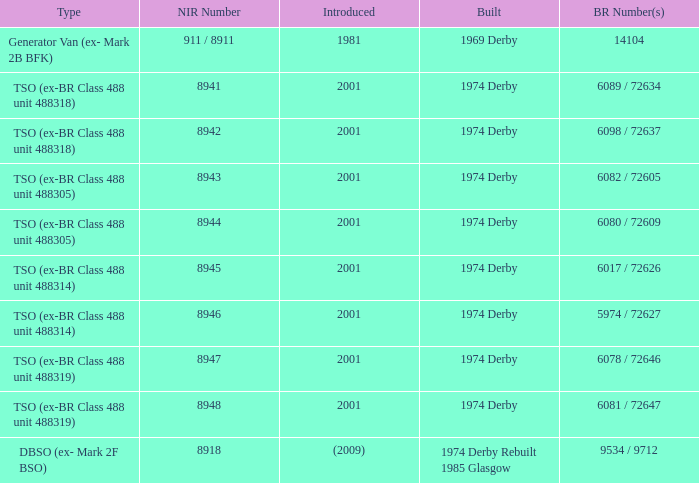Which NIR number is for the tso (ex-br class 488 unit 488305) type that has a 6082 / 72605 BR number? 8943.0. Could you parse the entire table? {'header': ['Type', 'NIR Number', 'Introduced', 'Built', 'BR Number(s)'], 'rows': [['Generator Van (ex- Mark 2B BFK)', '911 / 8911', '1981', '1969 Derby', '14104'], ['TSO (ex-BR Class 488 unit 488318)', '8941', '2001', '1974 Derby', '6089 / 72634'], ['TSO (ex-BR Class 488 unit 488318)', '8942', '2001', '1974 Derby', '6098 / 72637'], ['TSO (ex-BR Class 488 unit 488305)', '8943', '2001', '1974 Derby', '6082 / 72605'], ['TSO (ex-BR Class 488 unit 488305)', '8944', '2001', '1974 Derby', '6080 / 72609'], ['TSO (ex-BR Class 488 unit 488314)', '8945', '2001', '1974 Derby', '6017 / 72626'], ['TSO (ex-BR Class 488 unit 488314)', '8946', '2001', '1974 Derby', '5974 / 72627'], ['TSO (ex-BR Class 488 unit 488319)', '8947', '2001', '1974 Derby', '6078 / 72646'], ['TSO (ex-BR Class 488 unit 488319)', '8948', '2001', '1974 Derby', '6081 / 72647'], ['DBSO (ex- Mark 2F BSO)', '8918', '(2009)', '1974 Derby Rebuilt 1985 Glasgow', '9534 / 9712']]} 